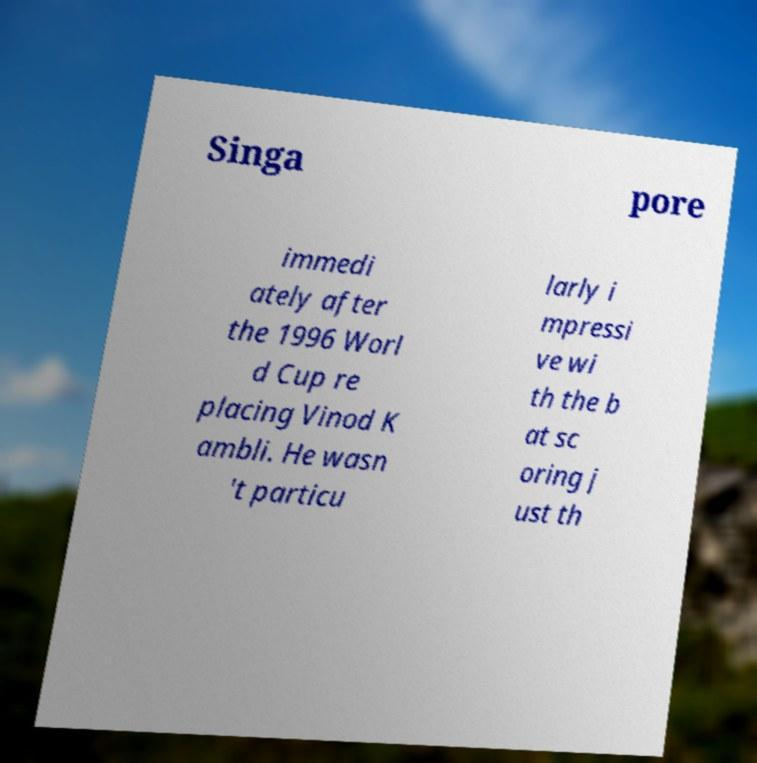Could you assist in decoding the text presented in this image and type it out clearly? Singa pore immedi ately after the 1996 Worl d Cup re placing Vinod K ambli. He wasn 't particu larly i mpressi ve wi th the b at sc oring j ust th 